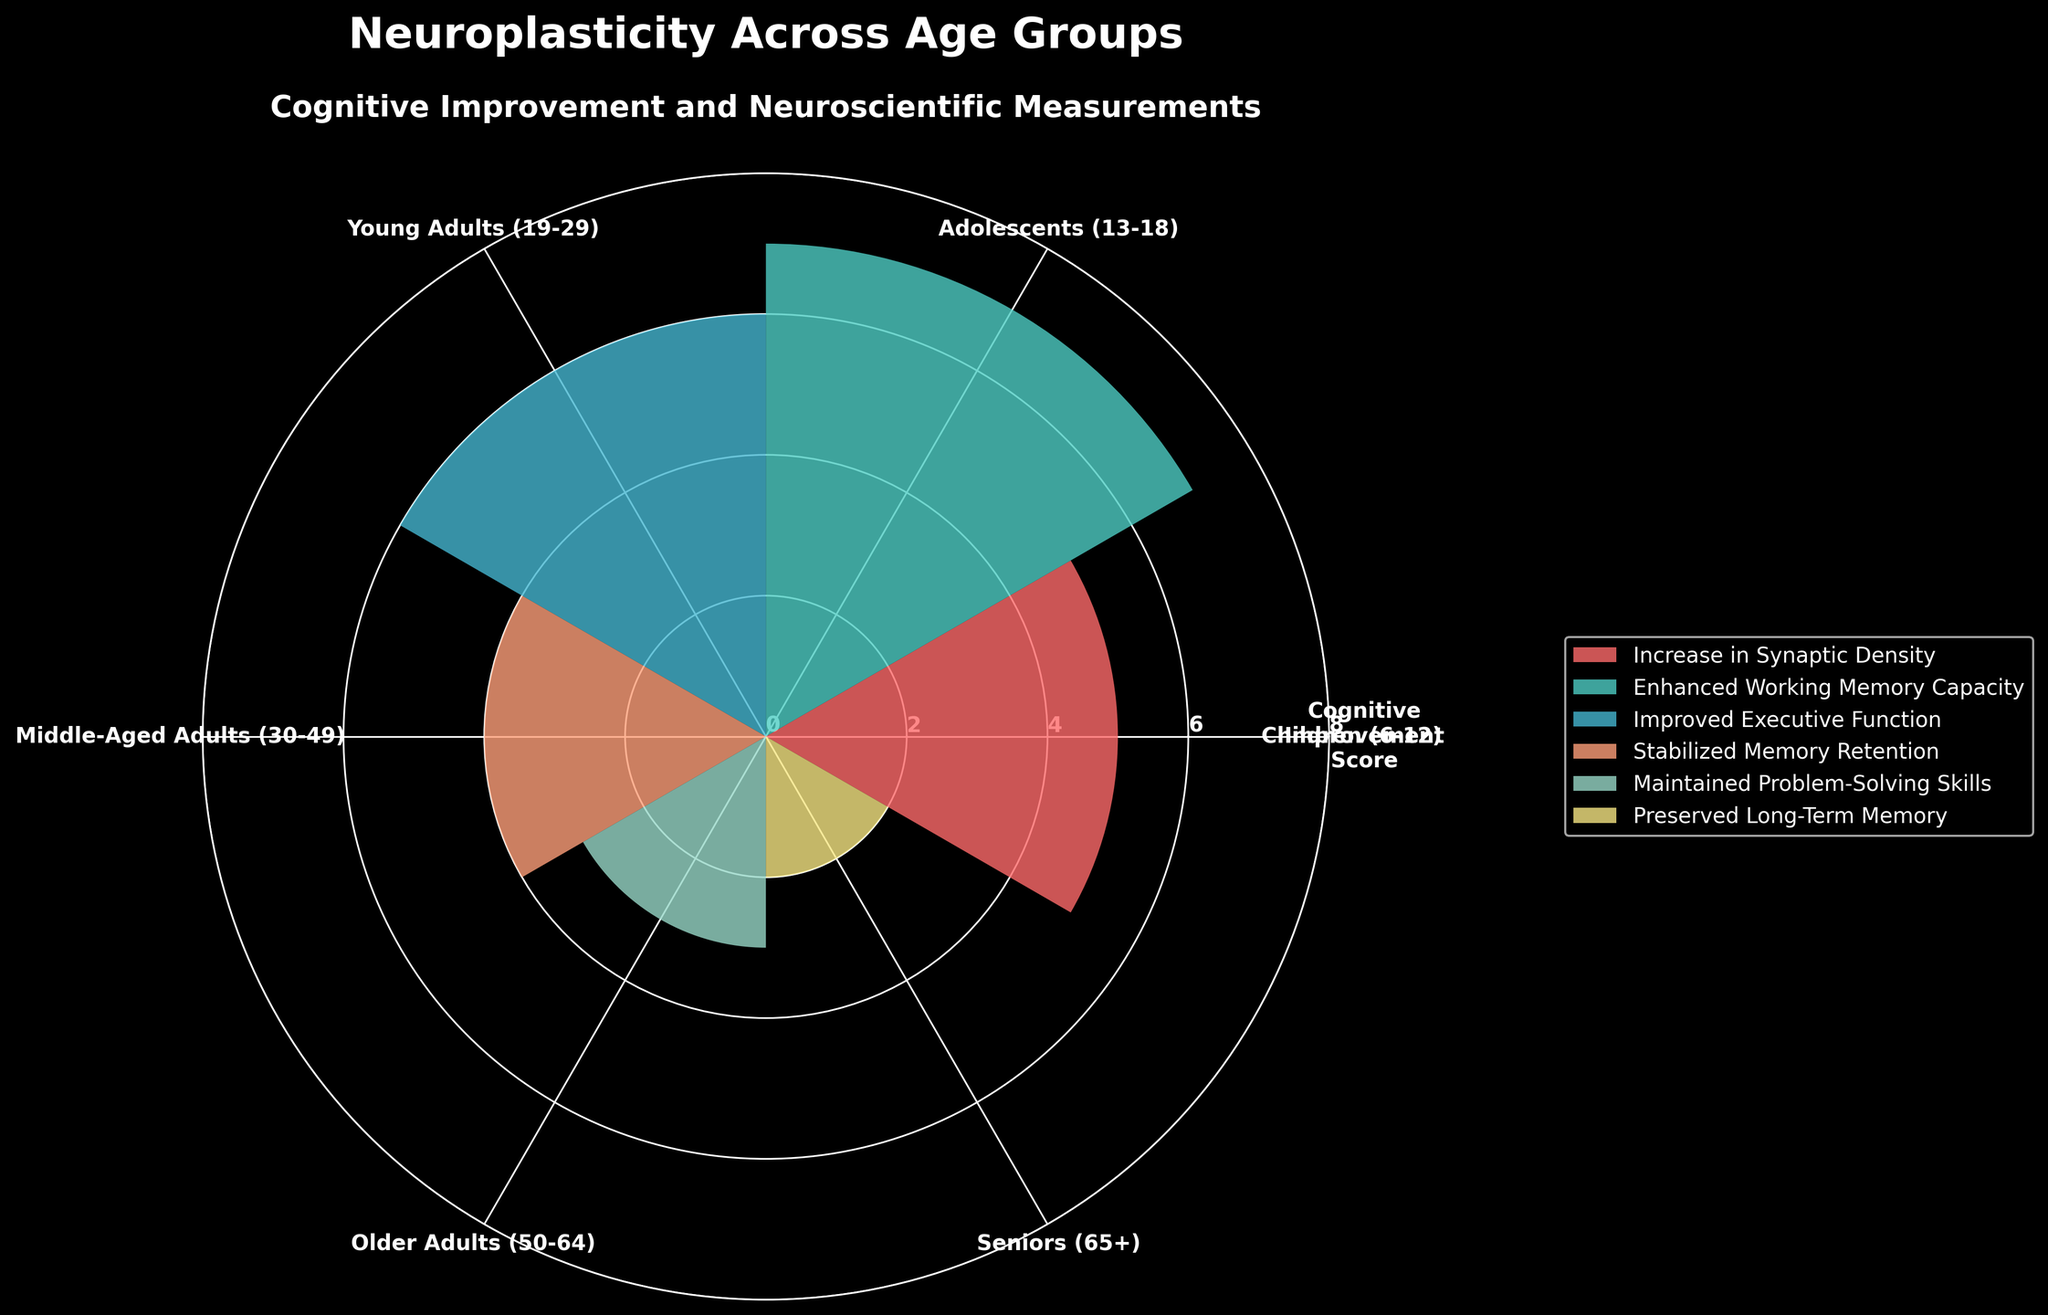what is the title of the plot The title of the plot is displayed at the top center. It reads "Neuroplasticity Across Age Groups"
Answer: Neuroplasticity Across Age Groups Which age group shows the highest cognitive improvement score? To find this, look at the bars' heights, each representing a different age group's cognitive improvement. The tallest bar corresponds to the Adolescents (13-18) category.
Answer: Adolescents (13-18) How many age groups are included in the plot? Each bar and corresponding label in the polar area chart represents an age group. Count the labels around the plot to determine this. There are six age groups.
Answer: Six Which age group has the lowest cognitive improvement score? Locate the shortest bar in the plot. The shortest bar represents the cognitive improvement score for Seniors (65+).
Answer: Seniors (65+) Compare the cognitive improvement score of Middle-Aged Adults and Older Adults. Which group has a higher score? Locate the bars for Middle-Aged Adults (30-49) and Older Adults (50-64). The bar for Middle-Aged Adults is taller, indicating a higher cognitive improvement score.
Answer: Middle-Aged Adults (30-49) What are the neuroscientific measurements associated with the Children and Young Adults age groups? Refer to the legend on the right side of the plot, which maps color to neuroscientific measurements, and match it to the colors of Children (6-12) and Young Adults (19-29). Children have an increase in synaptic density, and Young Adults have improved executive function.
Answer: Increase in Synaptic Density (Children), Improved Executive Function (Young Adults) What is the average cognitive improvement score across all age groups? To find the average, sum the cognitive improvement scores (5 + 7 + 6 + 4 + 3 + 2) and divide by the number of age groups (6). The sum is 27, and dividing by 6 gives the average.
Answer: 4.5 By how many points does the cognitive improvement score of Adolescents differ from that of Seniors? Subtract the cognitive improvement score of Seniors (2) from that of Adolescents (7). The difference is 5 points.
Answer: 5 points Which age group focuses on maintaining problem-solving skills as the neuroscientific measurement? Refer to the legend on the right side of the plot and match it to the bar color of Older Adults (50-64).
Answer: Older Adults (50-64) Is the average cognitive improvement score of individuals below 30 higher than of those 30 and above? To find this, calculate the average for individuals below 30 (Children, Adolescents, Young Adults) and for those 30 and above (Middle-Aged Adults, Older Adults, Seniors). Below 30: (5+7+6)/3 = 6. Above 30: (4+3+2)/3 = 3. The average score below 30 is higher by 3 points.
Answer: Yes 